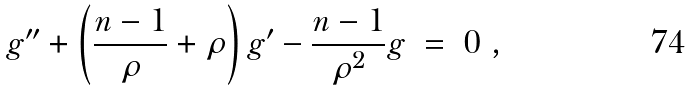Convert formula to latex. <formula><loc_0><loc_0><loc_500><loc_500>g ^ { \prime \prime } + \left ( \frac { n - 1 } { \rho } + \rho \right ) g ^ { \prime } - \frac { n - 1 } { \rho ^ { 2 } } g \ = \ 0 \ ,</formula> 